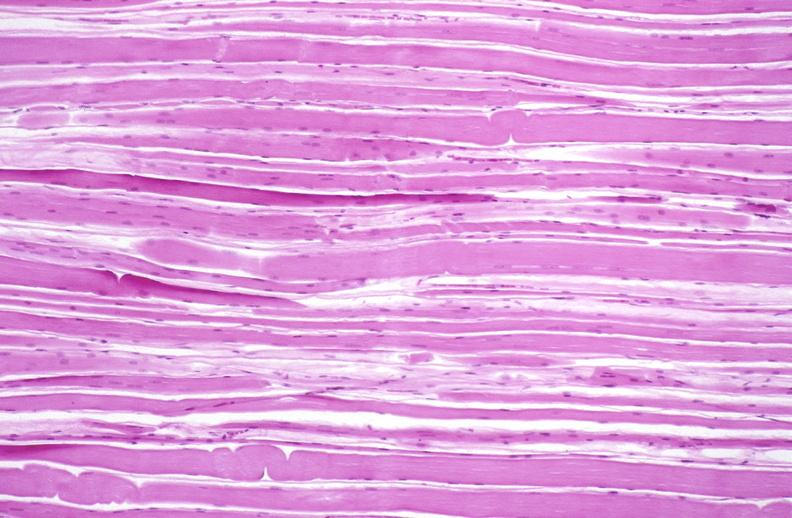s soft tissue present?
Answer the question using a single word or phrase. Yes 